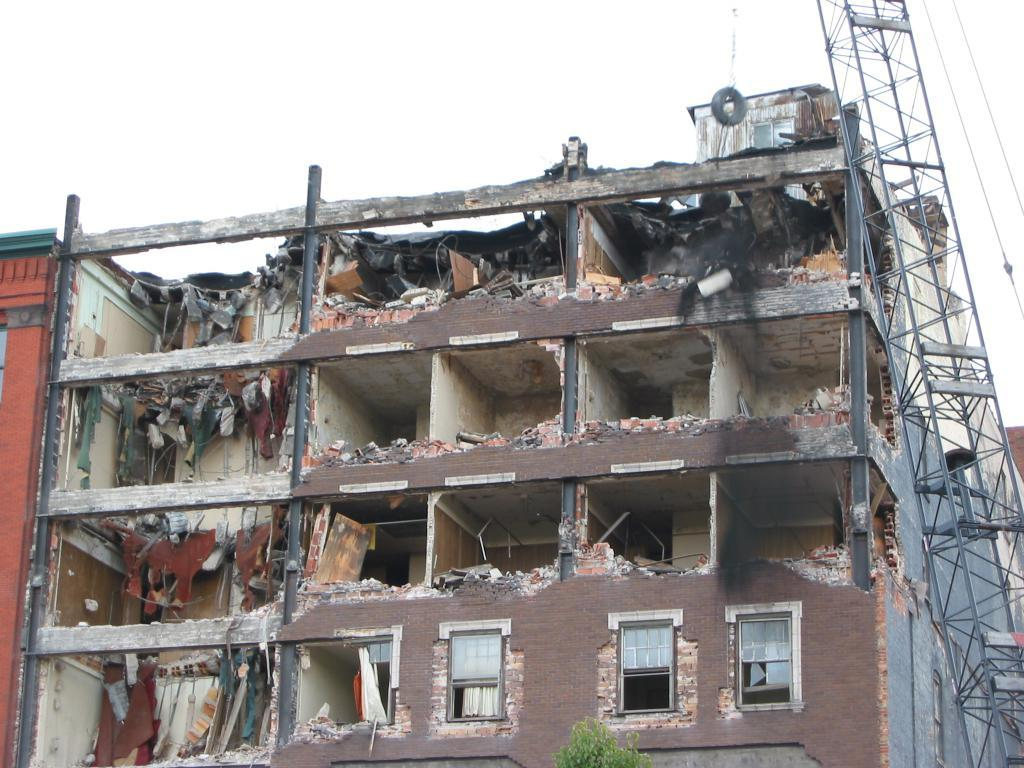What is happening to the building in the image? The building is under excavation in the image. What equipment can be seen on the right side of the image? There is a crane on the right side of the image. What can be seen in the background of the image? The sky is visible in the background of the image. How many secretaries are working in the building in the image? There is no information about secretaries or the number of secretaries in the image. 